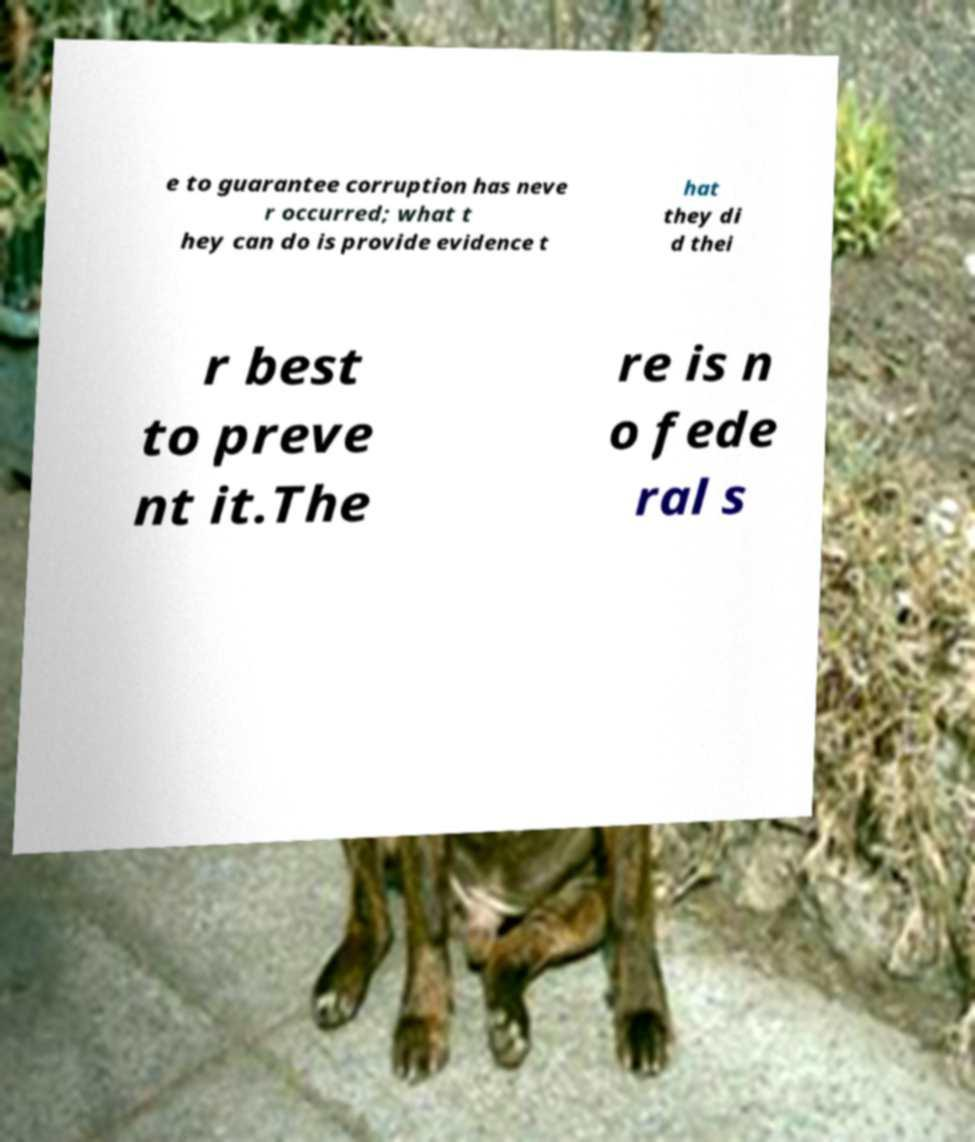Can you accurately transcribe the text from the provided image for me? e to guarantee corruption has neve r occurred; what t hey can do is provide evidence t hat they di d thei r best to preve nt it.The re is n o fede ral s 